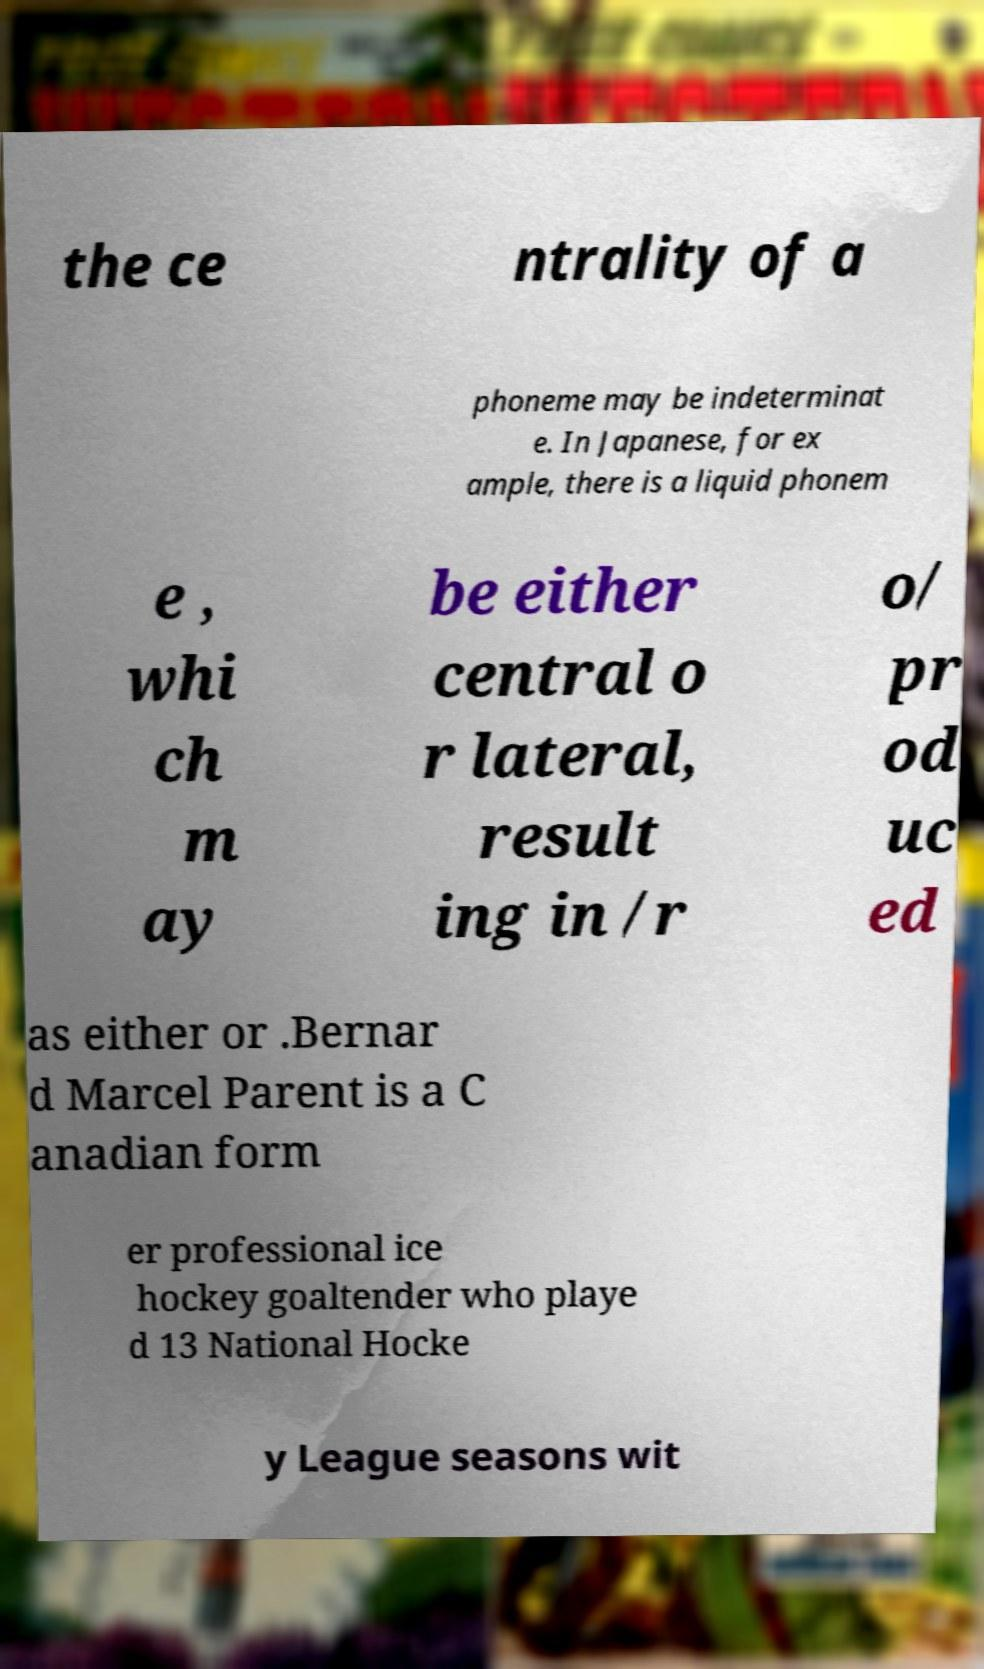I need the written content from this picture converted into text. Can you do that? the ce ntrality of a phoneme may be indeterminat e. In Japanese, for ex ample, there is a liquid phonem e , whi ch m ay be either central o r lateral, result ing in /r o/ pr od uc ed as either or .Bernar d Marcel Parent is a C anadian form er professional ice hockey goaltender who playe d 13 National Hocke y League seasons wit 